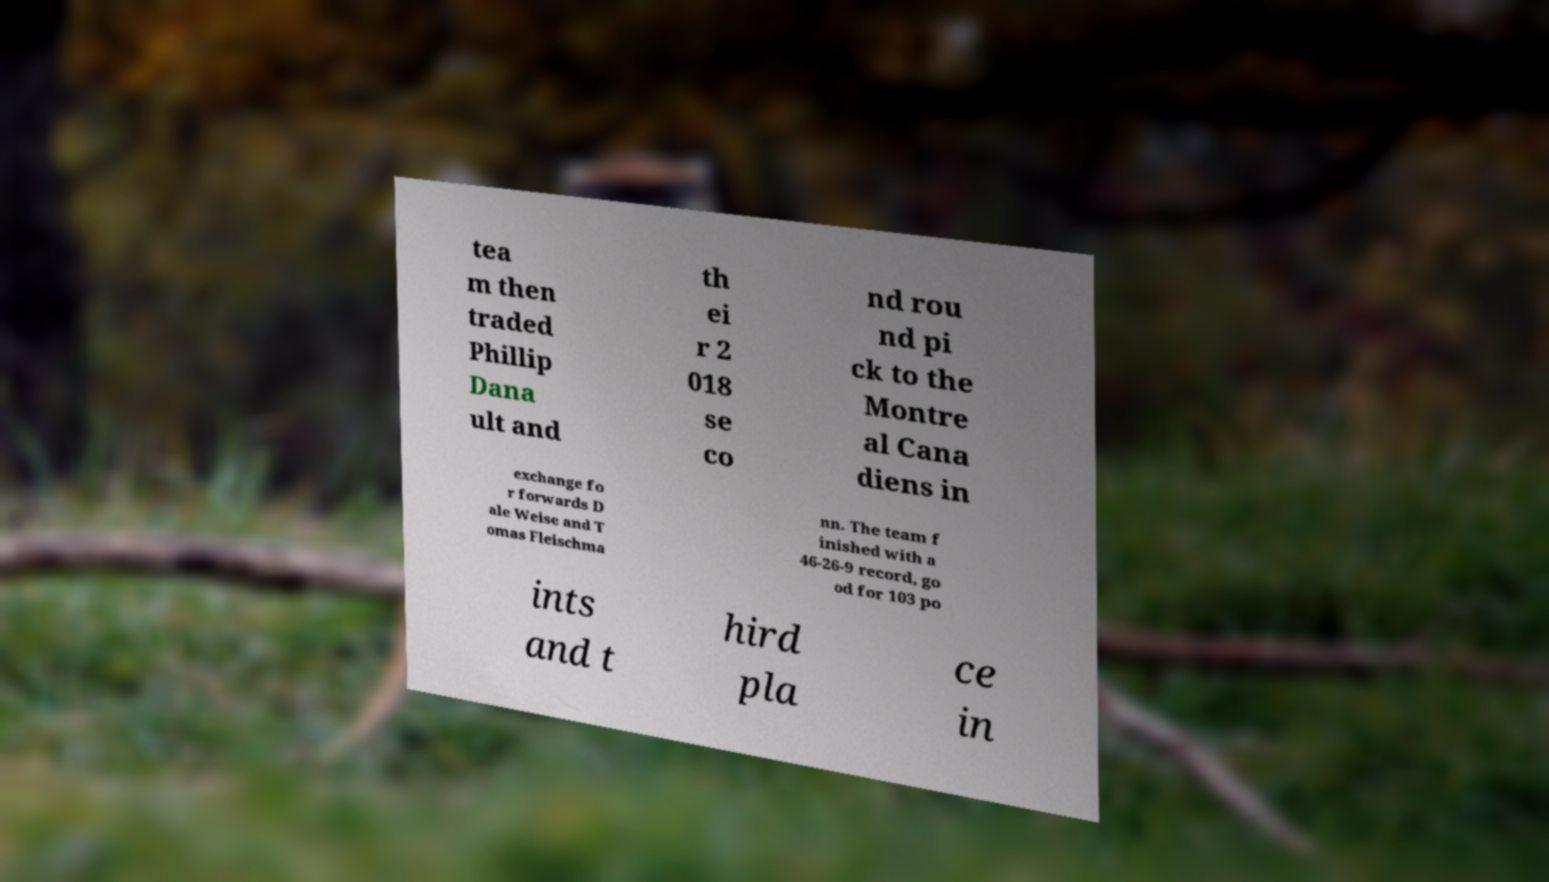I need the written content from this picture converted into text. Can you do that? tea m then traded Phillip Dana ult and th ei r 2 018 se co nd rou nd pi ck to the Montre al Cana diens in exchange fo r forwards D ale Weise and T omas Fleischma nn. The team f inished with a 46-26-9 record, go od for 103 po ints and t hird pla ce in 